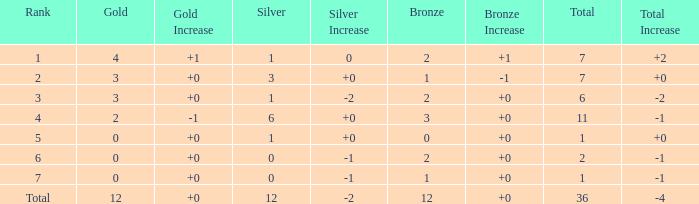What is the largest total for a team with 1 bronze, 0 gold medals and ranking of 7? None. Parse the full table. {'header': ['Rank', 'Gold', 'Gold Increase', 'Silver', 'Silver Increase', 'Bronze', 'Bronze Increase', 'Total', 'Total Increase'], 'rows': [['1', '4', '+1', '1', '0', '2', '+1', '7', '+2'], ['2', '3', '+0', '3', '+0', '1', '-1', '7', '+0'], ['3', '3', '+0', '1', '-2', '2', '+0', '6', '-2'], ['4', '2', '-1', '6', '+0', '3', '+0', '11', '-1'], ['5', '0', '+0', '1', '+0', '0', '+0', '1', '+0'], ['6', '0', '+0', '0', '-1', '2', '+0', '2', '-1'], ['7', '0', '+0', '0', '-1', '1', '+0', '1', '-1'], ['Total', '12', '+0', '12', '-2', '12', '+0', '36', '-4']]} 